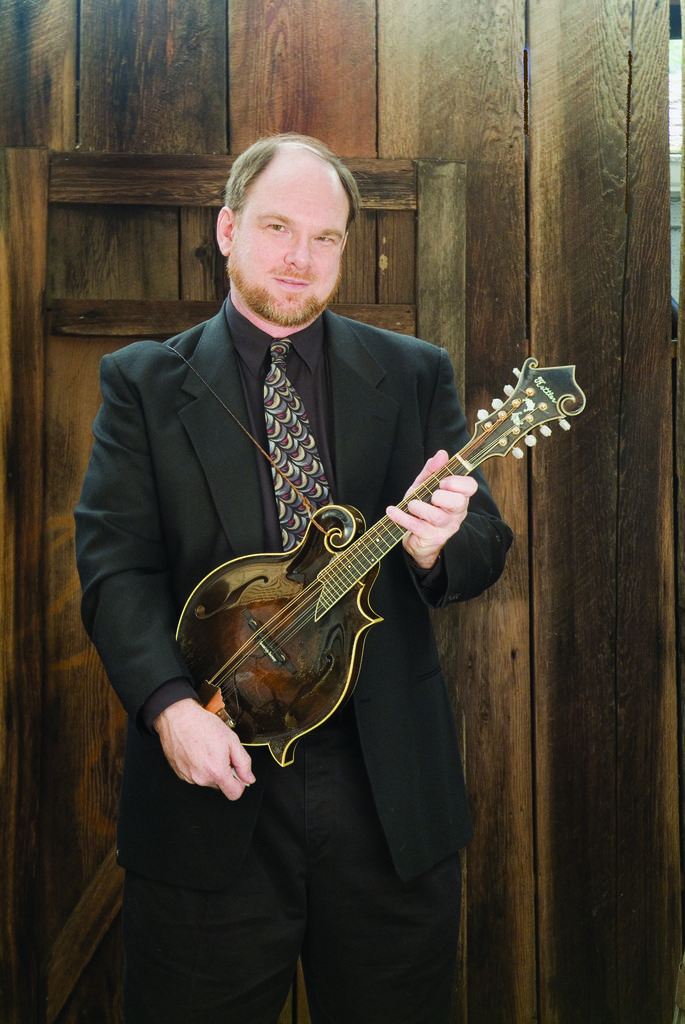In one or two sentences, can you explain what this image depicts? A man is holding guitar in his hand. 